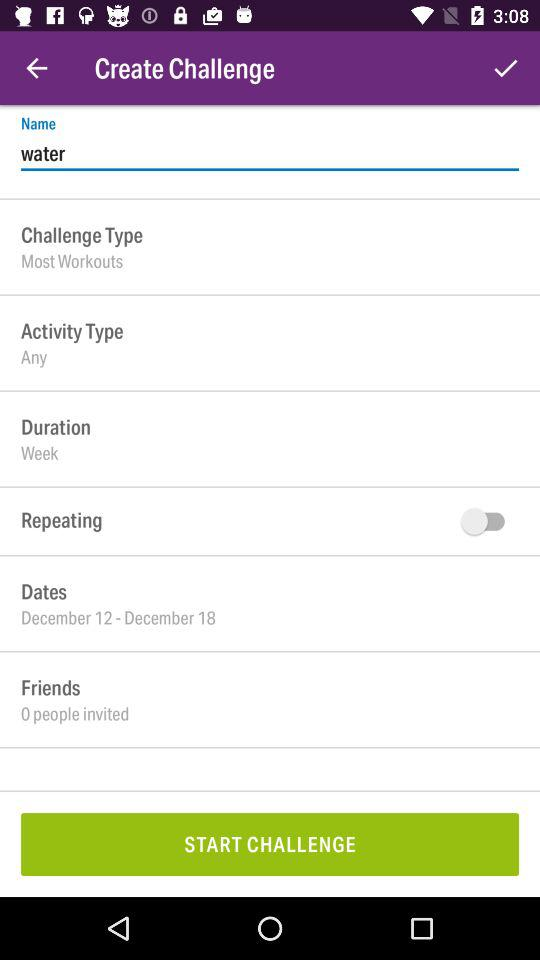What is the date range? The date range is from December 12 to December 18. 